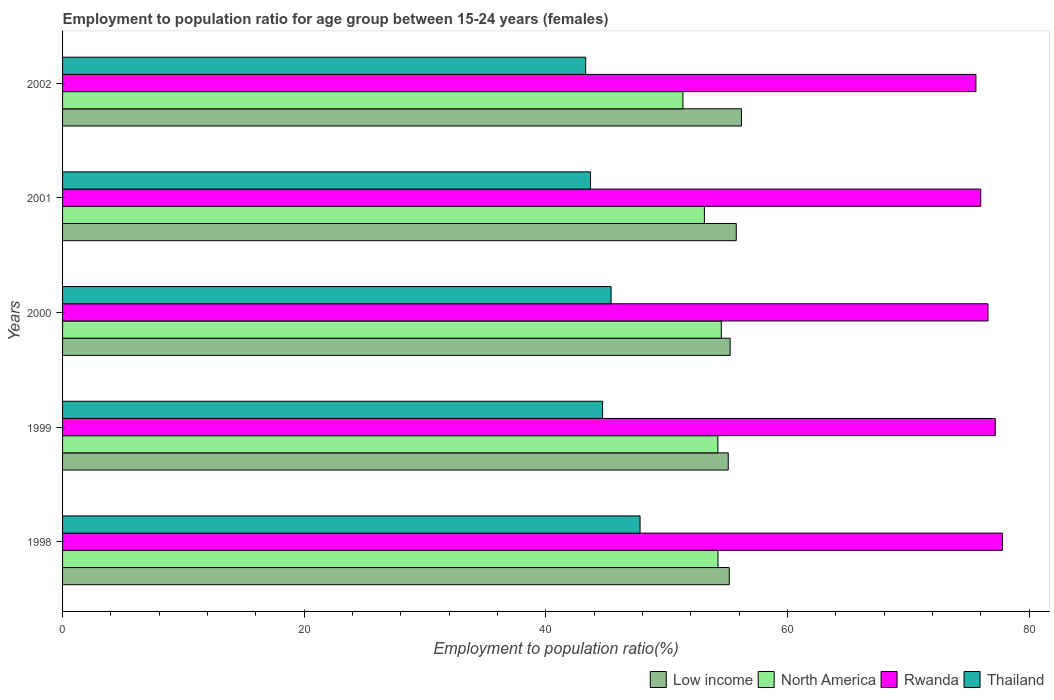How many different coloured bars are there?
Provide a short and direct response. 4. Are the number of bars on each tick of the Y-axis equal?
Ensure brevity in your answer.  Yes. How many bars are there on the 4th tick from the bottom?
Offer a terse response. 4. In how many cases, is the number of bars for a given year not equal to the number of legend labels?
Make the answer very short. 0. What is the employment to population ratio in Low income in 1998?
Keep it short and to the point. 55.18. Across all years, what is the maximum employment to population ratio in Thailand?
Give a very brief answer. 47.8. Across all years, what is the minimum employment to population ratio in Low income?
Your answer should be very brief. 55.1. In which year was the employment to population ratio in North America maximum?
Ensure brevity in your answer.  2000. What is the total employment to population ratio in Rwanda in the graph?
Your answer should be very brief. 383.2. What is the difference between the employment to population ratio in Low income in 1998 and that in 2002?
Give a very brief answer. -1.01. What is the difference between the employment to population ratio in Low income in 2000 and the employment to population ratio in Rwanda in 2001?
Offer a very short reply. -20.74. What is the average employment to population ratio in Rwanda per year?
Your response must be concise. 76.64. In the year 2000, what is the difference between the employment to population ratio in North America and employment to population ratio in Rwanda?
Provide a short and direct response. -22.08. In how many years, is the employment to population ratio in North America greater than 52 %?
Provide a succinct answer. 4. What is the ratio of the employment to population ratio in Rwanda in 2000 to that in 2001?
Make the answer very short. 1.01. Is the employment to population ratio in Rwanda in 2000 less than that in 2001?
Make the answer very short. No. What is the difference between the highest and the second highest employment to population ratio in North America?
Your answer should be very brief. 0.28. What is the difference between the highest and the lowest employment to population ratio in North America?
Make the answer very short. 3.18. Is the sum of the employment to population ratio in Thailand in 2001 and 2002 greater than the maximum employment to population ratio in Low income across all years?
Provide a succinct answer. Yes. Is it the case that in every year, the sum of the employment to population ratio in Rwanda and employment to population ratio in Thailand is greater than the sum of employment to population ratio in Low income and employment to population ratio in North America?
Provide a short and direct response. No. What does the 1st bar from the top in 2001 represents?
Ensure brevity in your answer.  Thailand. What does the 1st bar from the bottom in 1999 represents?
Your response must be concise. Low income. Are all the bars in the graph horizontal?
Keep it short and to the point. Yes. How many years are there in the graph?
Your answer should be very brief. 5. Are the values on the major ticks of X-axis written in scientific E-notation?
Your answer should be compact. No. Does the graph contain any zero values?
Your answer should be compact. No. How many legend labels are there?
Make the answer very short. 4. How are the legend labels stacked?
Provide a short and direct response. Horizontal. What is the title of the graph?
Your answer should be compact. Employment to population ratio for age group between 15-24 years (females). Does "Ghana" appear as one of the legend labels in the graph?
Your response must be concise. No. What is the label or title of the X-axis?
Provide a succinct answer. Employment to population ratio(%). What is the label or title of the Y-axis?
Your answer should be compact. Years. What is the Employment to population ratio(%) in Low income in 1998?
Keep it short and to the point. 55.18. What is the Employment to population ratio(%) in North America in 1998?
Ensure brevity in your answer.  54.25. What is the Employment to population ratio(%) in Rwanda in 1998?
Ensure brevity in your answer.  77.8. What is the Employment to population ratio(%) of Thailand in 1998?
Make the answer very short. 47.8. What is the Employment to population ratio(%) of Low income in 1999?
Keep it short and to the point. 55.1. What is the Employment to population ratio(%) in North America in 1999?
Make the answer very short. 54.24. What is the Employment to population ratio(%) of Rwanda in 1999?
Provide a short and direct response. 77.2. What is the Employment to population ratio(%) of Thailand in 1999?
Your answer should be very brief. 44.7. What is the Employment to population ratio(%) of Low income in 2000?
Make the answer very short. 55.26. What is the Employment to population ratio(%) of North America in 2000?
Your answer should be compact. 54.52. What is the Employment to population ratio(%) in Rwanda in 2000?
Your answer should be very brief. 76.6. What is the Employment to population ratio(%) of Thailand in 2000?
Keep it short and to the point. 45.4. What is the Employment to population ratio(%) of Low income in 2001?
Provide a succinct answer. 55.76. What is the Employment to population ratio(%) in North America in 2001?
Your answer should be compact. 53.13. What is the Employment to population ratio(%) of Rwanda in 2001?
Make the answer very short. 76. What is the Employment to population ratio(%) in Thailand in 2001?
Your answer should be very brief. 43.7. What is the Employment to population ratio(%) in Low income in 2002?
Make the answer very short. 56.19. What is the Employment to population ratio(%) in North America in 2002?
Your answer should be very brief. 51.35. What is the Employment to population ratio(%) in Rwanda in 2002?
Your answer should be very brief. 75.6. What is the Employment to population ratio(%) of Thailand in 2002?
Your response must be concise. 43.3. Across all years, what is the maximum Employment to population ratio(%) of Low income?
Your answer should be compact. 56.19. Across all years, what is the maximum Employment to population ratio(%) in North America?
Ensure brevity in your answer.  54.52. Across all years, what is the maximum Employment to population ratio(%) of Rwanda?
Your answer should be compact. 77.8. Across all years, what is the maximum Employment to population ratio(%) of Thailand?
Make the answer very short. 47.8. Across all years, what is the minimum Employment to population ratio(%) in Low income?
Keep it short and to the point. 55.1. Across all years, what is the minimum Employment to population ratio(%) of North America?
Provide a short and direct response. 51.35. Across all years, what is the minimum Employment to population ratio(%) of Rwanda?
Offer a very short reply. 75.6. Across all years, what is the minimum Employment to population ratio(%) of Thailand?
Offer a very short reply. 43.3. What is the total Employment to population ratio(%) in Low income in the graph?
Offer a very short reply. 277.49. What is the total Employment to population ratio(%) in North America in the graph?
Offer a very short reply. 267.49. What is the total Employment to population ratio(%) in Rwanda in the graph?
Provide a succinct answer. 383.2. What is the total Employment to population ratio(%) in Thailand in the graph?
Ensure brevity in your answer.  224.9. What is the difference between the Employment to population ratio(%) in Low income in 1998 and that in 1999?
Offer a very short reply. 0.08. What is the difference between the Employment to population ratio(%) of North America in 1998 and that in 1999?
Make the answer very short. 0.01. What is the difference between the Employment to population ratio(%) in Rwanda in 1998 and that in 1999?
Make the answer very short. 0.6. What is the difference between the Employment to population ratio(%) of Thailand in 1998 and that in 1999?
Provide a succinct answer. 3.1. What is the difference between the Employment to population ratio(%) in Low income in 1998 and that in 2000?
Ensure brevity in your answer.  -0.07. What is the difference between the Employment to population ratio(%) of North America in 1998 and that in 2000?
Your response must be concise. -0.28. What is the difference between the Employment to population ratio(%) in Thailand in 1998 and that in 2000?
Offer a terse response. 2.4. What is the difference between the Employment to population ratio(%) of Low income in 1998 and that in 2001?
Offer a terse response. -0.58. What is the difference between the Employment to population ratio(%) in North America in 1998 and that in 2001?
Your answer should be very brief. 1.12. What is the difference between the Employment to population ratio(%) of Thailand in 1998 and that in 2001?
Offer a very short reply. 4.1. What is the difference between the Employment to population ratio(%) of Low income in 1998 and that in 2002?
Provide a short and direct response. -1.01. What is the difference between the Employment to population ratio(%) in North America in 1998 and that in 2002?
Your answer should be very brief. 2.9. What is the difference between the Employment to population ratio(%) of Rwanda in 1998 and that in 2002?
Provide a short and direct response. 2.2. What is the difference between the Employment to population ratio(%) of Low income in 1999 and that in 2000?
Offer a very short reply. -0.16. What is the difference between the Employment to population ratio(%) in North America in 1999 and that in 2000?
Your answer should be compact. -0.28. What is the difference between the Employment to population ratio(%) of Low income in 1999 and that in 2001?
Ensure brevity in your answer.  -0.66. What is the difference between the Employment to population ratio(%) of North America in 1999 and that in 2001?
Keep it short and to the point. 1.12. What is the difference between the Employment to population ratio(%) in Low income in 1999 and that in 2002?
Your answer should be very brief. -1.09. What is the difference between the Employment to population ratio(%) of North America in 1999 and that in 2002?
Provide a short and direct response. 2.89. What is the difference between the Employment to population ratio(%) in Low income in 2000 and that in 2001?
Give a very brief answer. -0.5. What is the difference between the Employment to population ratio(%) of North America in 2000 and that in 2001?
Provide a succinct answer. 1.4. What is the difference between the Employment to population ratio(%) of Thailand in 2000 and that in 2001?
Your answer should be very brief. 1.7. What is the difference between the Employment to population ratio(%) of Low income in 2000 and that in 2002?
Offer a very short reply. -0.93. What is the difference between the Employment to population ratio(%) in North America in 2000 and that in 2002?
Give a very brief answer. 3.18. What is the difference between the Employment to population ratio(%) in Low income in 2001 and that in 2002?
Provide a short and direct response. -0.43. What is the difference between the Employment to population ratio(%) in North America in 2001 and that in 2002?
Your answer should be very brief. 1.78. What is the difference between the Employment to population ratio(%) in Thailand in 2001 and that in 2002?
Your answer should be very brief. 0.4. What is the difference between the Employment to population ratio(%) of Low income in 1998 and the Employment to population ratio(%) of North America in 1999?
Give a very brief answer. 0.94. What is the difference between the Employment to population ratio(%) of Low income in 1998 and the Employment to population ratio(%) of Rwanda in 1999?
Make the answer very short. -22.02. What is the difference between the Employment to population ratio(%) of Low income in 1998 and the Employment to population ratio(%) of Thailand in 1999?
Provide a short and direct response. 10.48. What is the difference between the Employment to population ratio(%) of North America in 1998 and the Employment to population ratio(%) of Rwanda in 1999?
Make the answer very short. -22.95. What is the difference between the Employment to population ratio(%) in North America in 1998 and the Employment to population ratio(%) in Thailand in 1999?
Ensure brevity in your answer.  9.55. What is the difference between the Employment to population ratio(%) in Rwanda in 1998 and the Employment to population ratio(%) in Thailand in 1999?
Offer a very short reply. 33.1. What is the difference between the Employment to population ratio(%) of Low income in 1998 and the Employment to population ratio(%) of North America in 2000?
Keep it short and to the point. 0.66. What is the difference between the Employment to population ratio(%) in Low income in 1998 and the Employment to population ratio(%) in Rwanda in 2000?
Keep it short and to the point. -21.42. What is the difference between the Employment to population ratio(%) in Low income in 1998 and the Employment to population ratio(%) in Thailand in 2000?
Provide a short and direct response. 9.78. What is the difference between the Employment to population ratio(%) in North America in 1998 and the Employment to population ratio(%) in Rwanda in 2000?
Ensure brevity in your answer.  -22.35. What is the difference between the Employment to population ratio(%) in North America in 1998 and the Employment to population ratio(%) in Thailand in 2000?
Your answer should be compact. 8.85. What is the difference between the Employment to population ratio(%) in Rwanda in 1998 and the Employment to population ratio(%) in Thailand in 2000?
Keep it short and to the point. 32.4. What is the difference between the Employment to population ratio(%) of Low income in 1998 and the Employment to population ratio(%) of North America in 2001?
Ensure brevity in your answer.  2.06. What is the difference between the Employment to population ratio(%) of Low income in 1998 and the Employment to population ratio(%) of Rwanda in 2001?
Offer a very short reply. -20.82. What is the difference between the Employment to population ratio(%) in Low income in 1998 and the Employment to population ratio(%) in Thailand in 2001?
Your answer should be very brief. 11.48. What is the difference between the Employment to population ratio(%) of North America in 1998 and the Employment to population ratio(%) of Rwanda in 2001?
Your answer should be very brief. -21.75. What is the difference between the Employment to population ratio(%) in North America in 1998 and the Employment to population ratio(%) in Thailand in 2001?
Ensure brevity in your answer.  10.55. What is the difference between the Employment to population ratio(%) of Rwanda in 1998 and the Employment to population ratio(%) of Thailand in 2001?
Your answer should be very brief. 34.1. What is the difference between the Employment to population ratio(%) in Low income in 1998 and the Employment to population ratio(%) in North America in 2002?
Keep it short and to the point. 3.83. What is the difference between the Employment to population ratio(%) of Low income in 1998 and the Employment to population ratio(%) of Rwanda in 2002?
Your answer should be very brief. -20.42. What is the difference between the Employment to population ratio(%) of Low income in 1998 and the Employment to population ratio(%) of Thailand in 2002?
Provide a short and direct response. 11.88. What is the difference between the Employment to population ratio(%) in North America in 1998 and the Employment to population ratio(%) in Rwanda in 2002?
Make the answer very short. -21.35. What is the difference between the Employment to population ratio(%) of North America in 1998 and the Employment to population ratio(%) of Thailand in 2002?
Give a very brief answer. 10.95. What is the difference between the Employment to population ratio(%) of Rwanda in 1998 and the Employment to population ratio(%) of Thailand in 2002?
Keep it short and to the point. 34.5. What is the difference between the Employment to population ratio(%) in Low income in 1999 and the Employment to population ratio(%) in North America in 2000?
Your response must be concise. 0.57. What is the difference between the Employment to population ratio(%) in Low income in 1999 and the Employment to population ratio(%) in Rwanda in 2000?
Your response must be concise. -21.5. What is the difference between the Employment to population ratio(%) in Low income in 1999 and the Employment to population ratio(%) in Thailand in 2000?
Your response must be concise. 9.7. What is the difference between the Employment to population ratio(%) of North America in 1999 and the Employment to population ratio(%) of Rwanda in 2000?
Provide a short and direct response. -22.36. What is the difference between the Employment to population ratio(%) of North America in 1999 and the Employment to population ratio(%) of Thailand in 2000?
Your answer should be compact. 8.84. What is the difference between the Employment to population ratio(%) in Rwanda in 1999 and the Employment to population ratio(%) in Thailand in 2000?
Offer a terse response. 31.8. What is the difference between the Employment to population ratio(%) in Low income in 1999 and the Employment to population ratio(%) in North America in 2001?
Make the answer very short. 1.97. What is the difference between the Employment to population ratio(%) in Low income in 1999 and the Employment to population ratio(%) in Rwanda in 2001?
Your answer should be very brief. -20.9. What is the difference between the Employment to population ratio(%) in Low income in 1999 and the Employment to population ratio(%) in Thailand in 2001?
Offer a very short reply. 11.4. What is the difference between the Employment to population ratio(%) of North America in 1999 and the Employment to population ratio(%) of Rwanda in 2001?
Your response must be concise. -21.76. What is the difference between the Employment to population ratio(%) of North America in 1999 and the Employment to population ratio(%) of Thailand in 2001?
Offer a terse response. 10.54. What is the difference between the Employment to population ratio(%) of Rwanda in 1999 and the Employment to population ratio(%) of Thailand in 2001?
Your answer should be very brief. 33.5. What is the difference between the Employment to population ratio(%) of Low income in 1999 and the Employment to population ratio(%) of North America in 2002?
Your answer should be compact. 3.75. What is the difference between the Employment to population ratio(%) of Low income in 1999 and the Employment to population ratio(%) of Rwanda in 2002?
Your answer should be compact. -20.5. What is the difference between the Employment to population ratio(%) of Low income in 1999 and the Employment to population ratio(%) of Thailand in 2002?
Your answer should be compact. 11.8. What is the difference between the Employment to population ratio(%) of North America in 1999 and the Employment to population ratio(%) of Rwanda in 2002?
Provide a short and direct response. -21.36. What is the difference between the Employment to population ratio(%) in North America in 1999 and the Employment to population ratio(%) in Thailand in 2002?
Your answer should be very brief. 10.94. What is the difference between the Employment to population ratio(%) of Rwanda in 1999 and the Employment to population ratio(%) of Thailand in 2002?
Make the answer very short. 33.9. What is the difference between the Employment to population ratio(%) in Low income in 2000 and the Employment to population ratio(%) in North America in 2001?
Offer a terse response. 2.13. What is the difference between the Employment to population ratio(%) in Low income in 2000 and the Employment to population ratio(%) in Rwanda in 2001?
Ensure brevity in your answer.  -20.74. What is the difference between the Employment to population ratio(%) in Low income in 2000 and the Employment to population ratio(%) in Thailand in 2001?
Offer a very short reply. 11.56. What is the difference between the Employment to population ratio(%) in North America in 2000 and the Employment to population ratio(%) in Rwanda in 2001?
Keep it short and to the point. -21.48. What is the difference between the Employment to population ratio(%) of North America in 2000 and the Employment to population ratio(%) of Thailand in 2001?
Give a very brief answer. 10.82. What is the difference between the Employment to population ratio(%) in Rwanda in 2000 and the Employment to population ratio(%) in Thailand in 2001?
Your response must be concise. 32.9. What is the difference between the Employment to population ratio(%) in Low income in 2000 and the Employment to population ratio(%) in North America in 2002?
Provide a short and direct response. 3.91. What is the difference between the Employment to population ratio(%) in Low income in 2000 and the Employment to population ratio(%) in Rwanda in 2002?
Your answer should be compact. -20.34. What is the difference between the Employment to population ratio(%) of Low income in 2000 and the Employment to population ratio(%) of Thailand in 2002?
Ensure brevity in your answer.  11.96. What is the difference between the Employment to population ratio(%) in North America in 2000 and the Employment to population ratio(%) in Rwanda in 2002?
Keep it short and to the point. -21.08. What is the difference between the Employment to population ratio(%) in North America in 2000 and the Employment to population ratio(%) in Thailand in 2002?
Your answer should be very brief. 11.22. What is the difference between the Employment to population ratio(%) of Rwanda in 2000 and the Employment to population ratio(%) of Thailand in 2002?
Provide a succinct answer. 33.3. What is the difference between the Employment to population ratio(%) in Low income in 2001 and the Employment to population ratio(%) in North America in 2002?
Your response must be concise. 4.41. What is the difference between the Employment to population ratio(%) of Low income in 2001 and the Employment to population ratio(%) of Rwanda in 2002?
Offer a very short reply. -19.84. What is the difference between the Employment to population ratio(%) in Low income in 2001 and the Employment to population ratio(%) in Thailand in 2002?
Give a very brief answer. 12.46. What is the difference between the Employment to population ratio(%) in North America in 2001 and the Employment to population ratio(%) in Rwanda in 2002?
Ensure brevity in your answer.  -22.47. What is the difference between the Employment to population ratio(%) in North America in 2001 and the Employment to population ratio(%) in Thailand in 2002?
Offer a terse response. 9.83. What is the difference between the Employment to population ratio(%) in Rwanda in 2001 and the Employment to population ratio(%) in Thailand in 2002?
Ensure brevity in your answer.  32.7. What is the average Employment to population ratio(%) in Low income per year?
Provide a short and direct response. 55.5. What is the average Employment to population ratio(%) in North America per year?
Give a very brief answer. 53.5. What is the average Employment to population ratio(%) of Rwanda per year?
Your answer should be very brief. 76.64. What is the average Employment to population ratio(%) in Thailand per year?
Give a very brief answer. 44.98. In the year 1998, what is the difference between the Employment to population ratio(%) of Low income and Employment to population ratio(%) of Rwanda?
Offer a very short reply. -22.62. In the year 1998, what is the difference between the Employment to population ratio(%) of Low income and Employment to population ratio(%) of Thailand?
Your answer should be compact. 7.38. In the year 1998, what is the difference between the Employment to population ratio(%) of North America and Employment to population ratio(%) of Rwanda?
Ensure brevity in your answer.  -23.55. In the year 1998, what is the difference between the Employment to population ratio(%) in North America and Employment to population ratio(%) in Thailand?
Keep it short and to the point. 6.45. In the year 1999, what is the difference between the Employment to population ratio(%) of Low income and Employment to population ratio(%) of North America?
Provide a short and direct response. 0.86. In the year 1999, what is the difference between the Employment to population ratio(%) in Low income and Employment to population ratio(%) in Rwanda?
Make the answer very short. -22.1. In the year 1999, what is the difference between the Employment to population ratio(%) in Low income and Employment to population ratio(%) in Thailand?
Offer a very short reply. 10.4. In the year 1999, what is the difference between the Employment to population ratio(%) of North America and Employment to population ratio(%) of Rwanda?
Ensure brevity in your answer.  -22.96. In the year 1999, what is the difference between the Employment to population ratio(%) in North America and Employment to population ratio(%) in Thailand?
Make the answer very short. 9.54. In the year 1999, what is the difference between the Employment to population ratio(%) in Rwanda and Employment to population ratio(%) in Thailand?
Ensure brevity in your answer.  32.5. In the year 2000, what is the difference between the Employment to population ratio(%) in Low income and Employment to population ratio(%) in North America?
Your answer should be compact. 0.73. In the year 2000, what is the difference between the Employment to population ratio(%) in Low income and Employment to population ratio(%) in Rwanda?
Offer a terse response. -21.34. In the year 2000, what is the difference between the Employment to population ratio(%) of Low income and Employment to population ratio(%) of Thailand?
Provide a short and direct response. 9.86. In the year 2000, what is the difference between the Employment to population ratio(%) in North America and Employment to population ratio(%) in Rwanda?
Your response must be concise. -22.08. In the year 2000, what is the difference between the Employment to population ratio(%) in North America and Employment to population ratio(%) in Thailand?
Make the answer very short. 9.12. In the year 2000, what is the difference between the Employment to population ratio(%) of Rwanda and Employment to population ratio(%) of Thailand?
Offer a terse response. 31.2. In the year 2001, what is the difference between the Employment to population ratio(%) in Low income and Employment to population ratio(%) in North America?
Keep it short and to the point. 2.64. In the year 2001, what is the difference between the Employment to population ratio(%) in Low income and Employment to population ratio(%) in Rwanda?
Your answer should be very brief. -20.24. In the year 2001, what is the difference between the Employment to population ratio(%) of Low income and Employment to population ratio(%) of Thailand?
Provide a short and direct response. 12.06. In the year 2001, what is the difference between the Employment to population ratio(%) in North America and Employment to population ratio(%) in Rwanda?
Provide a short and direct response. -22.87. In the year 2001, what is the difference between the Employment to population ratio(%) of North America and Employment to population ratio(%) of Thailand?
Provide a succinct answer. 9.43. In the year 2001, what is the difference between the Employment to population ratio(%) of Rwanda and Employment to population ratio(%) of Thailand?
Ensure brevity in your answer.  32.3. In the year 2002, what is the difference between the Employment to population ratio(%) of Low income and Employment to population ratio(%) of North America?
Ensure brevity in your answer.  4.84. In the year 2002, what is the difference between the Employment to population ratio(%) in Low income and Employment to population ratio(%) in Rwanda?
Ensure brevity in your answer.  -19.41. In the year 2002, what is the difference between the Employment to population ratio(%) of Low income and Employment to population ratio(%) of Thailand?
Keep it short and to the point. 12.89. In the year 2002, what is the difference between the Employment to population ratio(%) in North America and Employment to population ratio(%) in Rwanda?
Ensure brevity in your answer.  -24.25. In the year 2002, what is the difference between the Employment to population ratio(%) in North America and Employment to population ratio(%) in Thailand?
Your response must be concise. 8.05. In the year 2002, what is the difference between the Employment to population ratio(%) in Rwanda and Employment to population ratio(%) in Thailand?
Make the answer very short. 32.3. What is the ratio of the Employment to population ratio(%) of Low income in 1998 to that in 1999?
Offer a terse response. 1. What is the ratio of the Employment to population ratio(%) in Thailand in 1998 to that in 1999?
Your response must be concise. 1.07. What is the ratio of the Employment to population ratio(%) of Rwanda in 1998 to that in 2000?
Offer a terse response. 1.02. What is the ratio of the Employment to population ratio(%) of Thailand in 1998 to that in 2000?
Provide a short and direct response. 1.05. What is the ratio of the Employment to population ratio(%) of Low income in 1998 to that in 2001?
Your answer should be very brief. 0.99. What is the ratio of the Employment to population ratio(%) of North America in 1998 to that in 2001?
Make the answer very short. 1.02. What is the ratio of the Employment to population ratio(%) in Rwanda in 1998 to that in 2001?
Provide a succinct answer. 1.02. What is the ratio of the Employment to population ratio(%) of Thailand in 1998 to that in 2001?
Your answer should be compact. 1.09. What is the ratio of the Employment to population ratio(%) in Low income in 1998 to that in 2002?
Keep it short and to the point. 0.98. What is the ratio of the Employment to population ratio(%) in North America in 1998 to that in 2002?
Provide a succinct answer. 1.06. What is the ratio of the Employment to population ratio(%) in Rwanda in 1998 to that in 2002?
Keep it short and to the point. 1.03. What is the ratio of the Employment to population ratio(%) in Thailand in 1998 to that in 2002?
Keep it short and to the point. 1.1. What is the ratio of the Employment to population ratio(%) of Low income in 1999 to that in 2000?
Your answer should be compact. 1. What is the ratio of the Employment to population ratio(%) in Thailand in 1999 to that in 2000?
Make the answer very short. 0.98. What is the ratio of the Employment to population ratio(%) of Low income in 1999 to that in 2001?
Your response must be concise. 0.99. What is the ratio of the Employment to population ratio(%) in North America in 1999 to that in 2001?
Make the answer very short. 1.02. What is the ratio of the Employment to population ratio(%) of Rwanda in 1999 to that in 2001?
Ensure brevity in your answer.  1.02. What is the ratio of the Employment to population ratio(%) of Thailand in 1999 to that in 2001?
Offer a very short reply. 1.02. What is the ratio of the Employment to population ratio(%) of Low income in 1999 to that in 2002?
Your answer should be very brief. 0.98. What is the ratio of the Employment to population ratio(%) of North America in 1999 to that in 2002?
Provide a succinct answer. 1.06. What is the ratio of the Employment to population ratio(%) of Rwanda in 1999 to that in 2002?
Offer a very short reply. 1.02. What is the ratio of the Employment to population ratio(%) of Thailand in 1999 to that in 2002?
Offer a very short reply. 1.03. What is the ratio of the Employment to population ratio(%) of Low income in 2000 to that in 2001?
Offer a terse response. 0.99. What is the ratio of the Employment to population ratio(%) in North America in 2000 to that in 2001?
Make the answer very short. 1.03. What is the ratio of the Employment to population ratio(%) of Rwanda in 2000 to that in 2001?
Ensure brevity in your answer.  1.01. What is the ratio of the Employment to population ratio(%) of Thailand in 2000 to that in 2001?
Ensure brevity in your answer.  1.04. What is the ratio of the Employment to population ratio(%) in Low income in 2000 to that in 2002?
Your response must be concise. 0.98. What is the ratio of the Employment to population ratio(%) of North America in 2000 to that in 2002?
Your response must be concise. 1.06. What is the ratio of the Employment to population ratio(%) in Rwanda in 2000 to that in 2002?
Offer a terse response. 1.01. What is the ratio of the Employment to population ratio(%) of Thailand in 2000 to that in 2002?
Ensure brevity in your answer.  1.05. What is the ratio of the Employment to population ratio(%) in Low income in 2001 to that in 2002?
Provide a succinct answer. 0.99. What is the ratio of the Employment to population ratio(%) in North America in 2001 to that in 2002?
Provide a short and direct response. 1.03. What is the ratio of the Employment to population ratio(%) of Rwanda in 2001 to that in 2002?
Your response must be concise. 1.01. What is the ratio of the Employment to population ratio(%) of Thailand in 2001 to that in 2002?
Offer a terse response. 1.01. What is the difference between the highest and the second highest Employment to population ratio(%) of Low income?
Ensure brevity in your answer.  0.43. What is the difference between the highest and the second highest Employment to population ratio(%) in North America?
Offer a terse response. 0.28. What is the difference between the highest and the second highest Employment to population ratio(%) in Rwanda?
Offer a terse response. 0.6. What is the difference between the highest and the lowest Employment to population ratio(%) in Low income?
Your answer should be very brief. 1.09. What is the difference between the highest and the lowest Employment to population ratio(%) of North America?
Offer a very short reply. 3.18. What is the difference between the highest and the lowest Employment to population ratio(%) of Rwanda?
Offer a terse response. 2.2. 